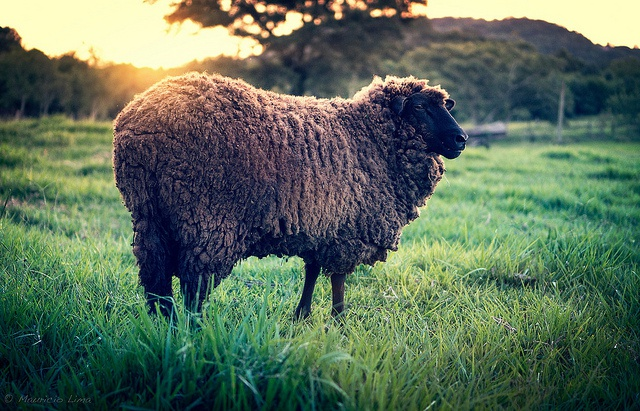Describe the objects in this image and their specific colors. I can see a sheep in lightyellow, navy, and gray tones in this image. 